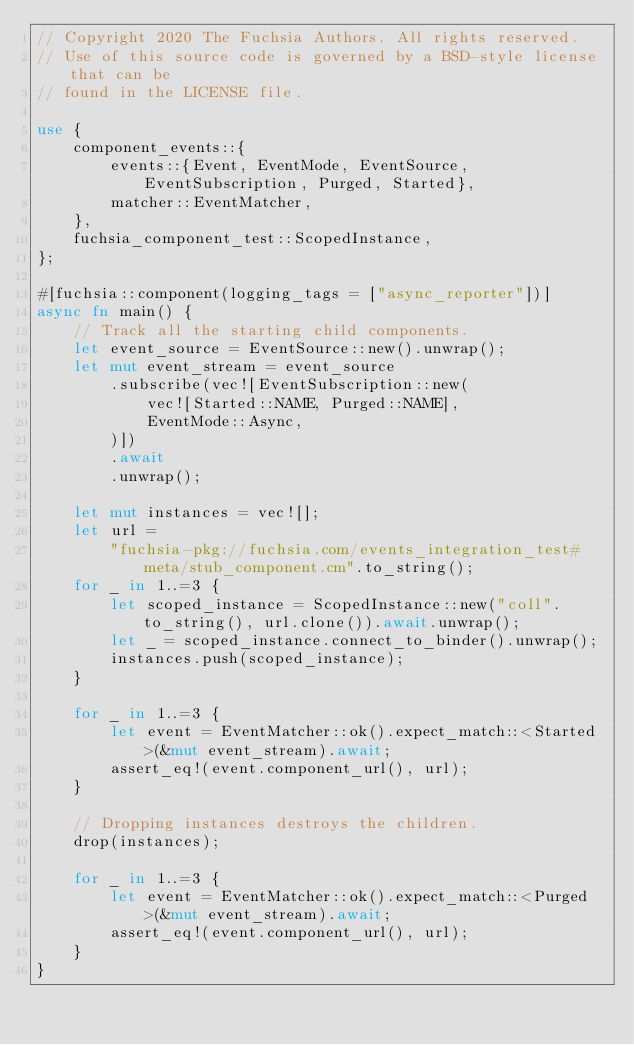Convert code to text. <code><loc_0><loc_0><loc_500><loc_500><_Rust_>// Copyright 2020 The Fuchsia Authors. All rights reserved.
// Use of this source code is governed by a BSD-style license that can be
// found in the LICENSE file.

use {
    component_events::{
        events::{Event, EventMode, EventSource, EventSubscription, Purged, Started},
        matcher::EventMatcher,
    },
    fuchsia_component_test::ScopedInstance,
};

#[fuchsia::component(logging_tags = ["async_reporter"])]
async fn main() {
    // Track all the starting child components.
    let event_source = EventSource::new().unwrap();
    let mut event_stream = event_source
        .subscribe(vec![EventSubscription::new(
            vec![Started::NAME, Purged::NAME],
            EventMode::Async,
        )])
        .await
        .unwrap();

    let mut instances = vec![];
    let url =
        "fuchsia-pkg://fuchsia.com/events_integration_test#meta/stub_component.cm".to_string();
    for _ in 1..=3 {
        let scoped_instance = ScopedInstance::new("coll".to_string(), url.clone()).await.unwrap();
        let _ = scoped_instance.connect_to_binder().unwrap();
        instances.push(scoped_instance);
    }

    for _ in 1..=3 {
        let event = EventMatcher::ok().expect_match::<Started>(&mut event_stream).await;
        assert_eq!(event.component_url(), url);
    }

    // Dropping instances destroys the children.
    drop(instances);

    for _ in 1..=3 {
        let event = EventMatcher::ok().expect_match::<Purged>(&mut event_stream).await;
        assert_eq!(event.component_url(), url);
    }
}
</code> 